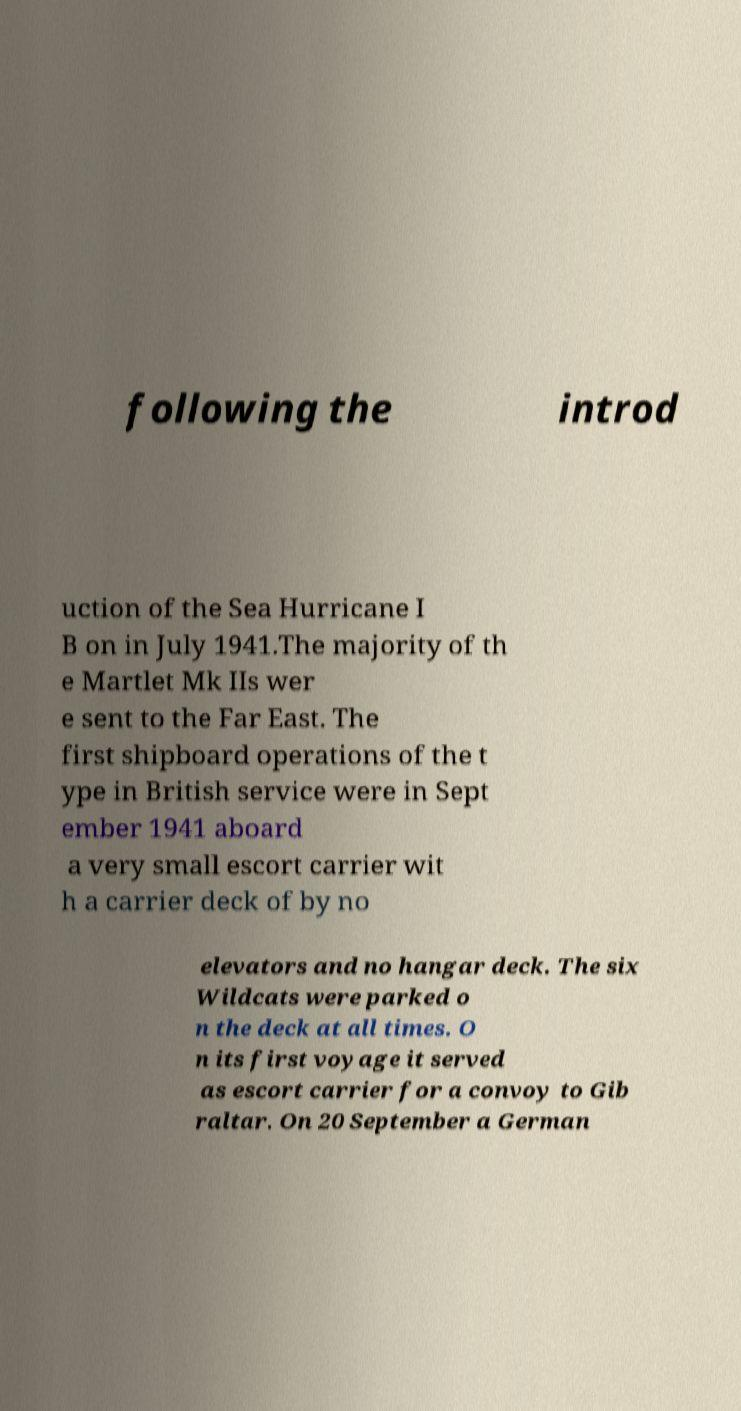Could you assist in decoding the text presented in this image and type it out clearly? following the introd uction of the Sea Hurricane I B on in July 1941.The majority of th e Martlet Mk IIs wer e sent to the Far East. The first shipboard operations of the t ype in British service were in Sept ember 1941 aboard a very small escort carrier wit h a carrier deck of by no elevators and no hangar deck. The six Wildcats were parked o n the deck at all times. O n its first voyage it served as escort carrier for a convoy to Gib raltar. On 20 September a German 